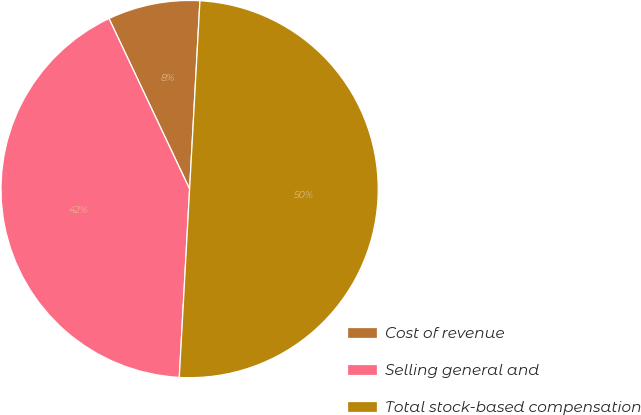Convert chart. <chart><loc_0><loc_0><loc_500><loc_500><pie_chart><fcel>Cost of revenue<fcel>Selling general and<fcel>Total stock-based compensation<nl><fcel>7.9%<fcel>42.1%<fcel>50.0%<nl></chart> 